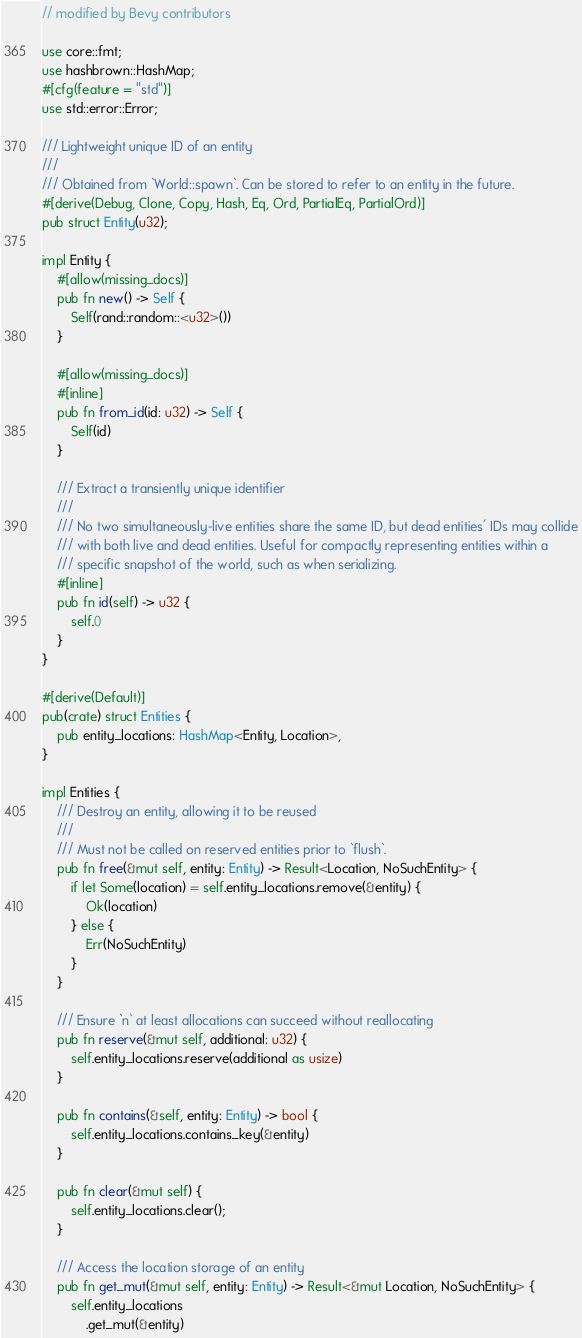<code> <loc_0><loc_0><loc_500><loc_500><_Rust_>// modified by Bevy contributors

use core::fmt;
use hashbrown::HashMap;
#[cfg(feature = "std")]
use std::error::Error;

/// Lightweight unique ID of an entity
///
/// Obtained from `World::spawn`. Can be stored to refer to an entity in the future.
#[derive(Debug, Clone, Copy, Hash, Eq, Ord, PartialEq, PartialOrd)]
pub struct Entity(u32);

impl Entity {
    #[allow(missing_docs)]
    pub fn new() -> Self {
        Self(rand::random::<u32>())
    }

    #[allow(missing_docs)]
    #[inline]
    pub fn from_id(id: u32) -> Self {
        Self(id)
    }

    /// Extract a transiently unique identifier
    ///
    /// No two simultaneously-live entities share the same ID, but dead entities' IDs may collide
    /// with both live and dead entities. Useful for compactly representing entities within a
    /// specific snapshot of the world, such as when serializing.
    #[inline]
    pub fn id(self) -> u32 {
        self.0
    }
}

#[derive(Default)]
pub(crate) struct Entities {
    pub entity_locations: HashMap<Entity, Location>,
}

impl Entities {
    /// Destroy an entity, allowing it to be reused
    ///
    /// Must not be called on reserved entities prior to `flush`.
    pub fn free(&mut self, entity: Entity) -> Result<Location, NoSuchEntity> {
        if let Some(location) = self.entity_locations.remove(&entity) {
            Ok(location)
        } else {
            Err(NoSuchEntity)
        }
    }

    /// Ensure `n` at least allocations can succeed without reallocating
    pub fn reserve(&mut self, additional: u32) {
        self.entity_locations.reserve(additional as usize)
    }

    pub fn contains(&self, entity: Entity) -> bool {
        self.entity_locations.contains_key(&entity)
    }

    pub fn clear(&mut self) {
        self.entity_locations.clear();
    }

    /// Access the location storage of an entity
    pub fn get_mut(&mut self, entity: Entity) -> Result<&mut Location, NoSuchEntity> {
        self.entity_locations
            .get_mut(&entity)</code> 